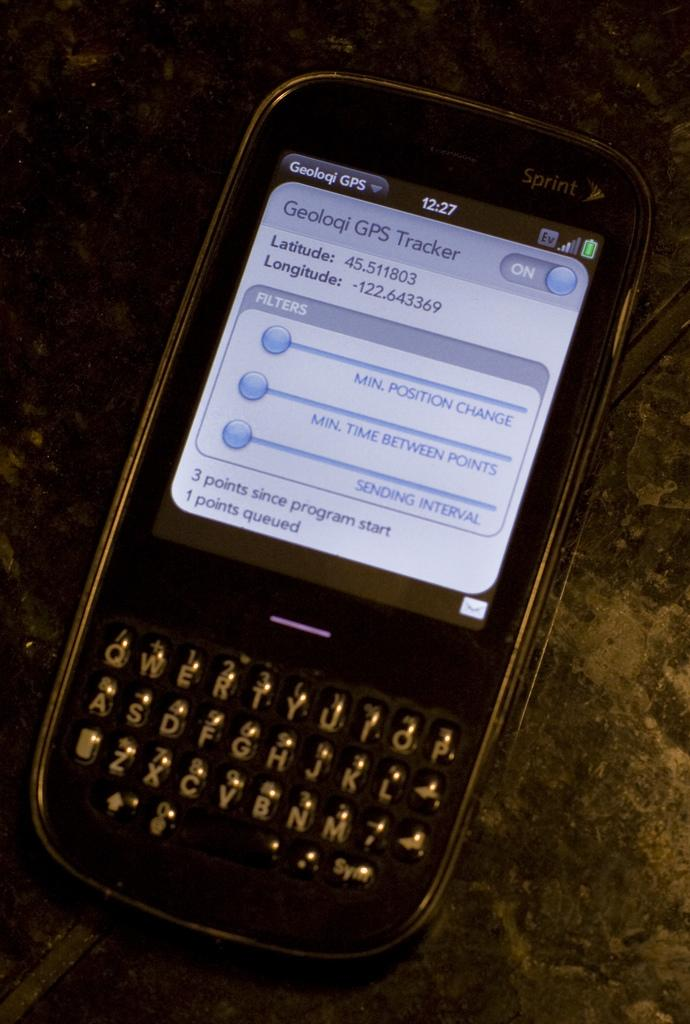<image>
Give a short and clear explanation of the subsequent image. A phone with a Geoloqi GPS Tracker pulled up on the screen. 